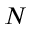Convert formula to latex. <formula><loc_0><loc_0><loc_500><loc_500>N</formula> 